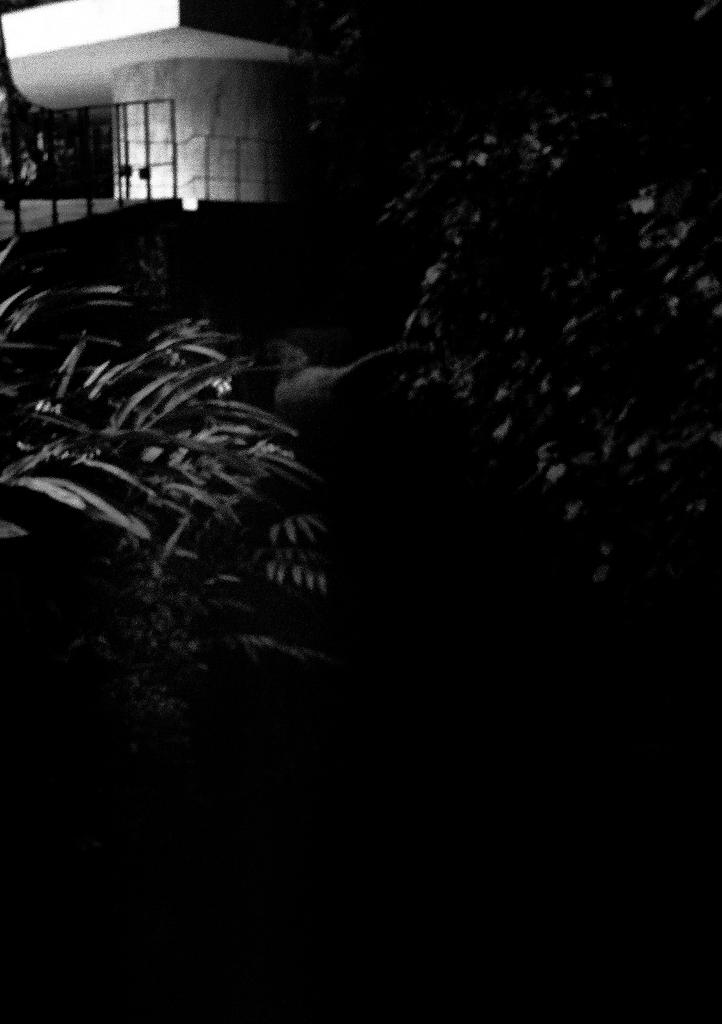What is the color scheme of the image? The image is black and white. What type of natural elements can be seen in the image? There are plants in the image. What type of structure is present in the image? There is a fence in the image. Can you describe the unspecified object in the image? Unfortunately, the facts provided do not give any details about the unspecified object. What type of harmony can be heard in the image? There is no sound or music present in the image, so it is not possible to determine any type of harmony. 